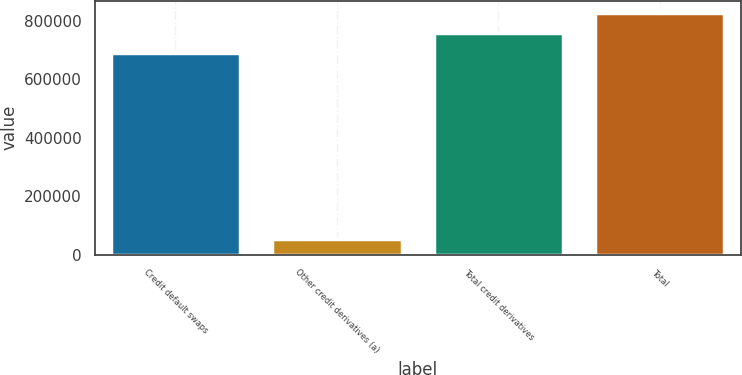Convert chart to OTSL. <chart><loc_0><loc_0><loc_500><loc_500><bar_chart><fcel>Credit default swaps<fcel>Other credit derivatives (a)<fcel>Total credit derivatives<fcel>Total<nl><fcel>690224<fcel>54157<fcel>759248<fcel>828272<nl></chart> 